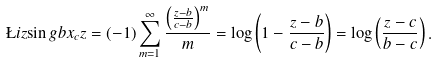Convert formula to latex. <formula><loc_0><loc_0><loc_500><loc_500>\L i z { \sin g } { b } { x _ { c } } { z } = ( - 1 ) \sum _ { m = 1 } ^ { \infty } \frac { \left ( \frac { z - b } { c - b } \right ) ^ { m } } { m } = \log \left ( 1 - \frac { z - b } { c - b } \right ) = \log \left ( \frac { z - c } { b - c } \right ) .</formula> 